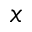<formula> <loc_0><loc_0><loc_500><loc_500>x</formula> 